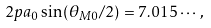Convert formula to latex. <formula><loc_0><loc_0><loc_500><loc_500>2 p a _ { 0 } \sin ( \theta _ { M 0 } / 2 ) = 7 . 0 1 5 \cdots ,</formula> 